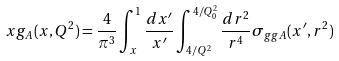<formula> <loc_0><loc_0><loc_500><loc_500>x g _ { A } ( x , Q ^ { 2 } ) = \frac { 4 } { \pi ^ { 3 } } \int _ { x } ^ { 1 } \frac { d x ^ { \prime } } { x ^ { \prime } } \int _ { 4 / Q ^ { 2 } } ^ { 4 / Q _ { 0 } ^ { 2 } } \frac { d r ^ { 2 } } { r ^ { 4 } } \sigma _ { g g A } ( x ^ { \prime } , r ^ { 2 } )</formula> 